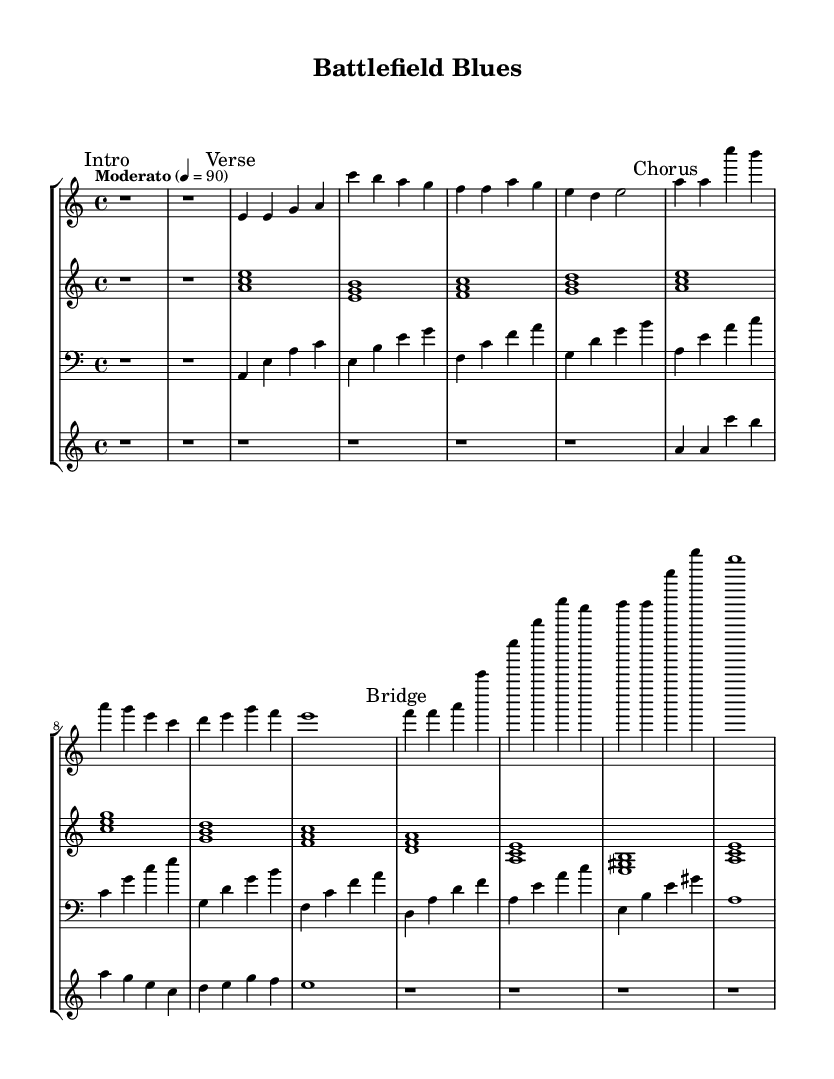What is the key signature of this music? The key signature shown at the beginning of the score indicates A minor, which has no sharps or flats, as it corresponds to the relative minor of C major.
Answer: A minor What is the time signature of this music? The time signature appears after the key signature, indicating that this piece is written in a 4/4 time, meaning there are four beats in each measure and a quarter note receives one beat.
Answer: 4/4 What is the tempo marking for this piece? The tempo marking is specified as "Moderato" and the corresponding metronome mark indicates that the quarter note should be played at a speed of 90 beats per minute, indicating a moderate pace.
Answer: Moderato, 90 How many staves are in the score? The score consists of four individual staves representing different instruments, which are the piano, electric guitar, bass, and trumpet.
Answer: Four What is the primary function of the electric guitar in this piece? The electric guitar typically provides harmonic support and emphasizes the emotional tones; in this case, it plays chords throughout, complementing the overall bluesy character of the fusion.
Answer: Harmonic support Which section features the melody prominently? The chorus section of the piece features the melody prominently, as indicated by the marked section in the score where the notes clearly outline the melodic line played by the piano and trumpet.
Answer: Chorus What genre influence is evident in this fusion piece? The piece exhibits clear blues influences, characterized by the use of specific chord progressions and emotional expression associated with blues music, highlighting the emotional toll of war reporting.
Answer: Blues 